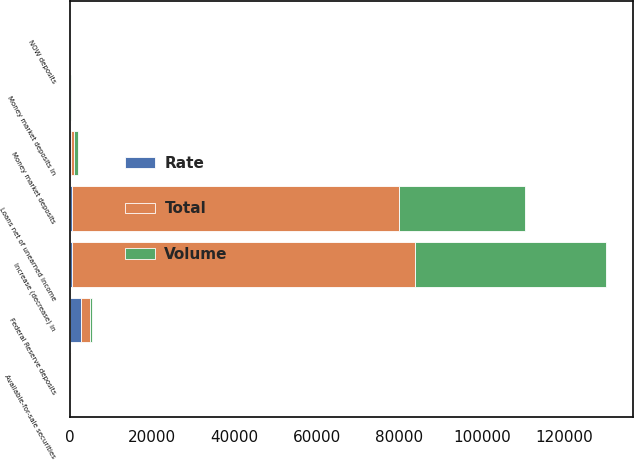Convert chart. <chart><loc_0><loc_0><loc_500><loc_500><stacked_bar_chart><ecel><fcel>Federal Reserve deposits<fcel>Available-for-sale securities<fcel>Loans net of unearned income<fcel>Increase (decrease) in<fcel>NOW deposits<fcel>Money market deposits<fcel>Money market deposits in<nl><fcel>Rate<fcel>2701<fcel>160<fcel>476.5<fcel>476.5<fcel>58<fcel>391<fcel>10<nl><fcel>Volume<fcel>360<fcel>69<fcel>30636<fcel>46357<fcel>15<fcel>953<fcel>160<nl><fcel>Total<fcel>2341<fcel>91<fcel>79316<fcel>83298<fcel>73<fcel>562<fcel>170<nl></chart> 